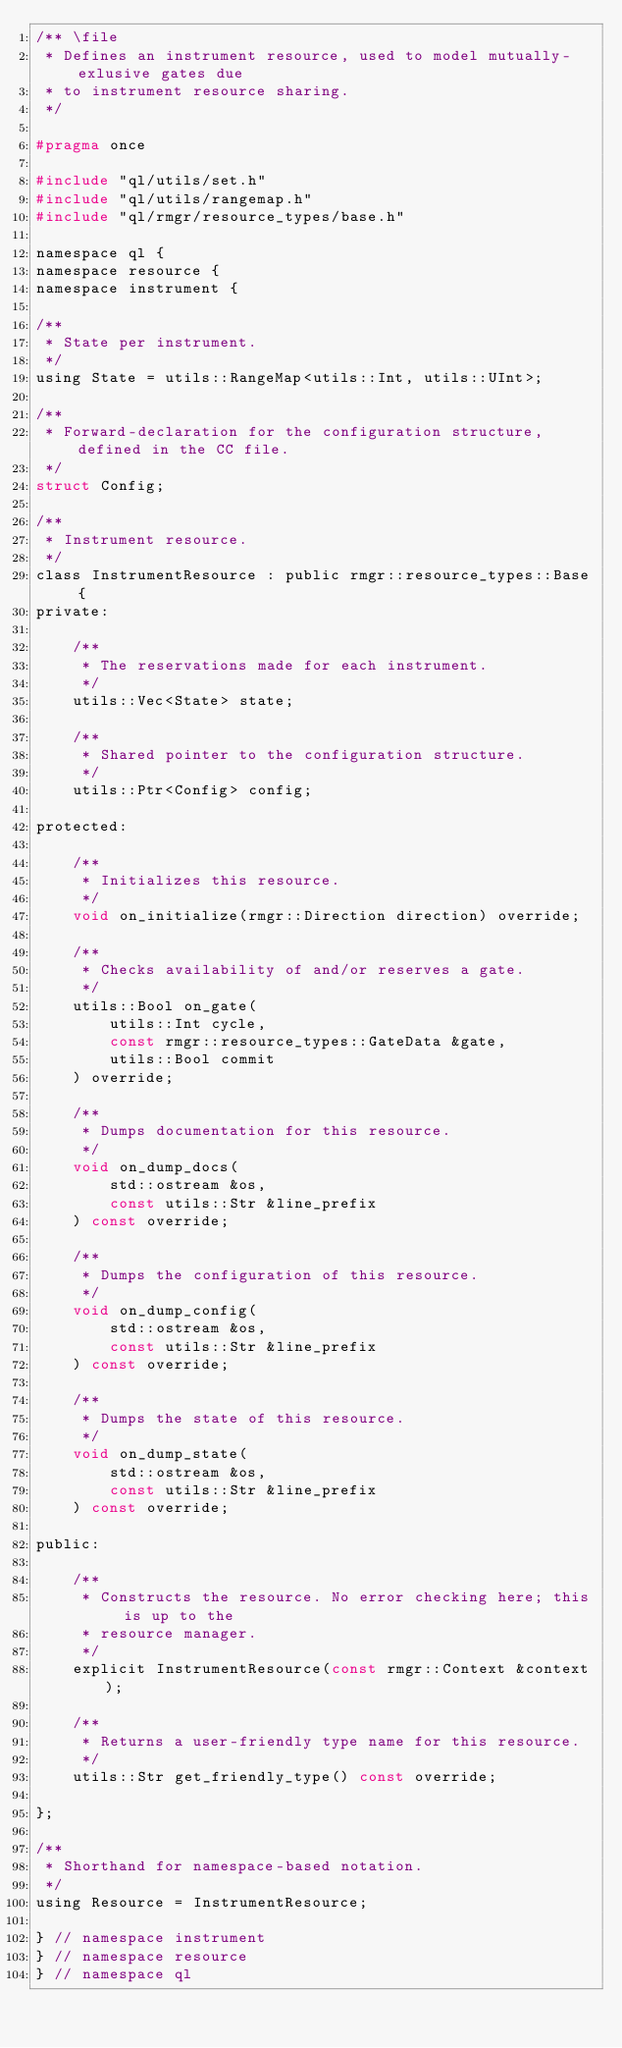Convert code to text. <code><loc_0><loc_0><loc_500><loc_500><_C_>/** \file
 * Defines an instrument resource, used to model mutually-exlusive gates due
 * to instrument resource sharing.
 */

#pragma once

#include "ql/utils/set.h"
#include "ql/utils/rangemap.h"
#include "ql/rmgr/resource_types/base.h"

namespace ql {
namespace resource {
namespace instrument {

/**
 * State per instrument.
 */
using State = utils::RangeMap<utils::Int, utils::UInt>;

/**
 * Forward-declaration for the configuration structure, defined in the CC file.
 */
struct Config;

/**
 * Instrument resource.
 */
class InstrumentResource : public rmgr::resource_types::Base {
private:

    /**
     * The reservations made for each instrument.
     */
    utils::Vec<State> state;

    /**
     * Shared pointer to the configuration structure.
     */
    utils::Ptr<Config> config;

protected:

    /**
     * Initializes this resource.
     */
    void on_initialize(rmgr::Direction direction) override;

    /**
     * Checks availability of and/or reserves a gate.
     */
    utils::Bool on_gate(
        utils::Int cycle,
        const rmgr::resource_types::GateData &gate,
        utils::Bool commit
    ) override;

    /**
     * Dumps documentation for this resource.
     */
    void on_dump_docs(
        std::ostream &os,
        const utils::Str &line_prefix
    ) const override;

    /**
     * Dumps the configuration of this resource.
     */
    void on_dump_config(
        std::ostream &os,
        const utils::Str &line_prefix
    ) const override;

    /**
     * Dumps the state of this resource.
     */
    void on_dump_state(
        std::ostream &os,
        const utils::Str &line_prefix
    ) const override;

public:

    /**
     * Constructs the resource. No error checking here; this is up to the
     * resource manager.
     */
    explicit InstrumentResource(const rmgr::Context &context);

    /**
     * Returns a user-friendly type name for this resource.
     */
    utils::Str get_friendly_type() const override;

};

/**
 * Shorthand for namespace-based notation.
 */
using Resource = InstrumentResource;

} // namespace instrument
} // namespace resource
} // namespace ql
</code> 